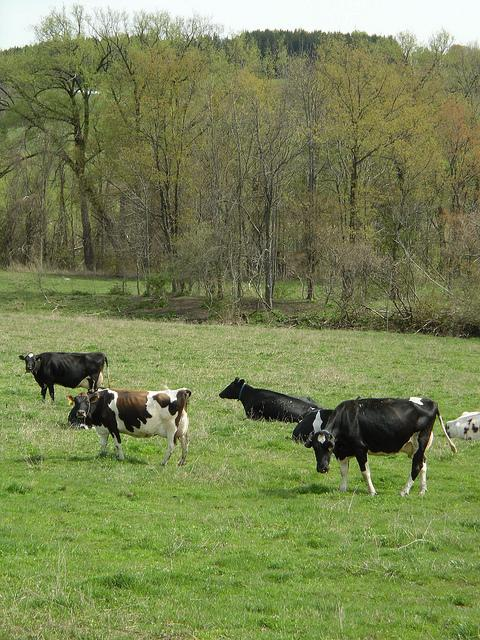What color is the strange cow just ahead to the left? Please explain your reasoning. brown. The color isn't black like the others, and is a mixture of red and yellow to make a soil type color. 